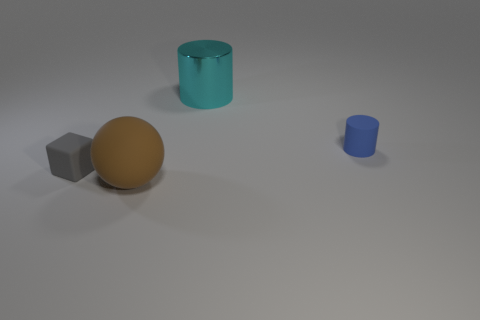Could you describe the lighting and mood conveyed in this scene? The scene has a soft, diffused lighting with shadows indicating a light source coming from the top right corner. The overall mood is calm and tranquil, enhanced by the neutral colors and uncluttered composition. 